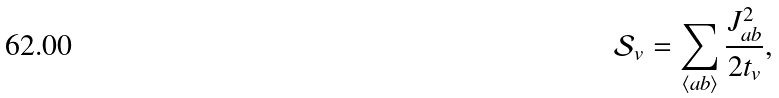<formula> <loc_0><loc_0><loc_500><loc_500>\mathcal { S } _ { v } = \sum _ { \langle a b \rangle } \frac { J _ { a b } ^ { 2 } } { 2 t _ { v } } ,</formula> 